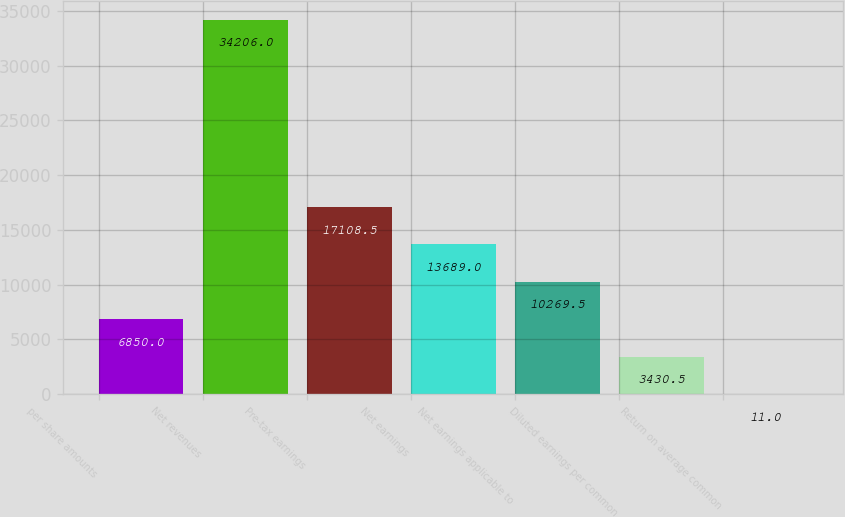Convert chart to OTSL. <chart><loc_0><loc_0><loc_500><loc_500><bar_chart><fcel>per share amounts<fcel>Net revenues<fcel>Pre-tax earnings<fcel>Net earnings<fcel>Net earnings applicable to<fcel>Diluted earnings per common<fcel>Return on average common<nl><fcel>6850<fcel>34206<fcel>17108.5<fcel>13689<fcel>10269.5<fcel>3430.5<fcel>11<nl></chart> 